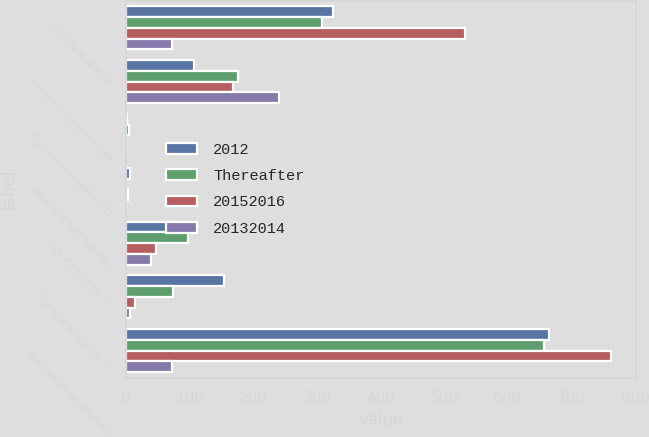Convert chart to OTSL. <chart><loc_0><loc_0><loc_500><loc_500><stacked_bar_chart><ecel><fcel>Long-term debt (1)<fcel>Interest on long-term debt<fcel>Capitallease obligations(2)<fcel>Other long-term liabilities<fcel>Operating leases (4)<fcel>Purchase obligations (5)<fcel>Total contractual obligations<nl><fcel>2012<fcel>325.2<fcel>106.3<fcel>1.8<fcel>5.5<fcel>72.2<fcel>153.4<fcel>664.4<nl><fcel>Thereafter<fcel>308.5<fcel>175<fcel>3.9<fcel>0<fcel>96.7<fcel>73.2<fcel>657.3<nl><fcel>20152016<fcel>532.8<fcel>167.7<fcel>0<fcel>2<fcel>46.6<fcel>13.7<fcel>762.8<nl><fcel>20132014<fcel>72.7<fcel>239.6<fcel>0<fcel>0<fcel>39.3<fcel>5.8<fcel>72.7<nl></chart> 